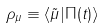<formula> <loc_0><loc_0><loc_500><loc_500>\rho _ { \mu } \equiv \langle \tilde { \mu } | \Pi ( t ) \rangle</formula> 